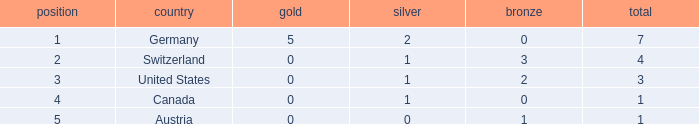What is the full amount of Total for Austria when the number of gold is less than 0? None. 